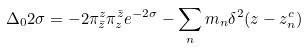Convert formula to latex. <formula><loc_0><loc_0><loc_500><loc_500>\Delta _ { 0 } 2 \sigma = - 2 \pi ^ { z } _ { \bar { z } } \pi ^ { \bar { z } } _ { z } e ^ { - 2 \sigma } - \sum _ { n } m _ { n } \delta ^ { 2 } ( z - z _ { n } ^ { c } )</formula> 